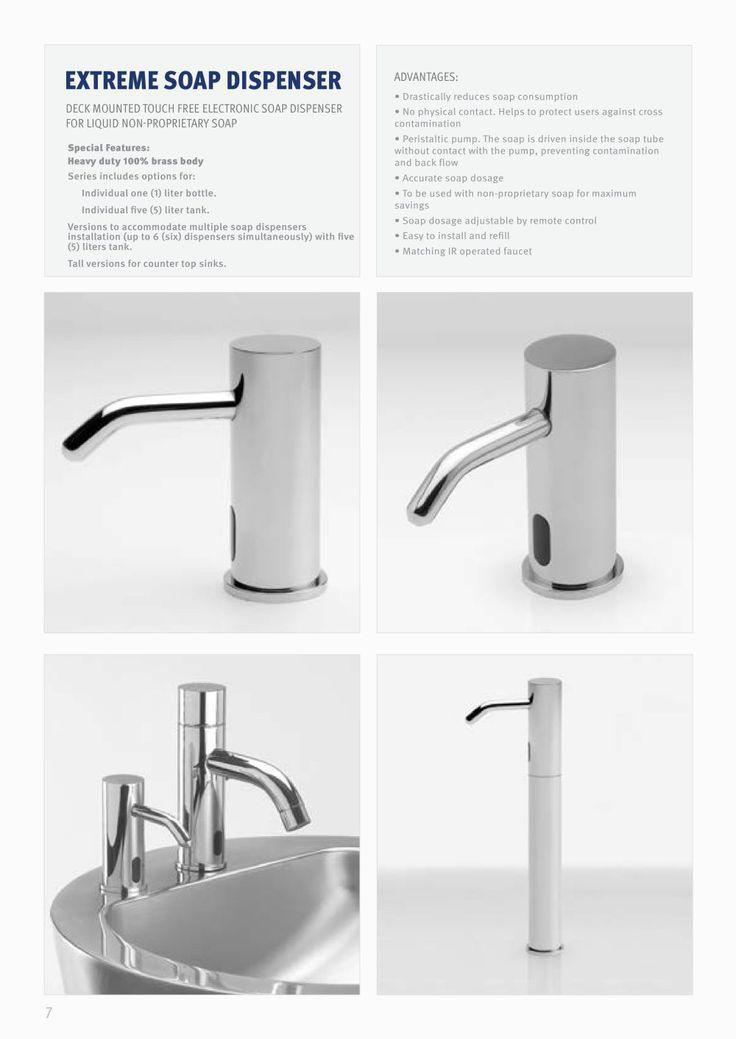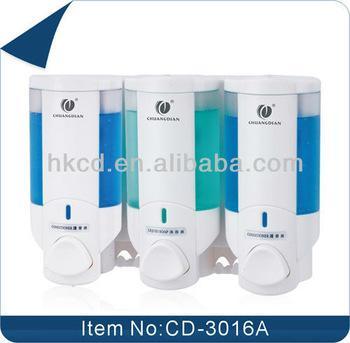The first image is the image on the left, the second image is the image on the right. Examine the images to the left and right. Is the description "1 of the images has 3 dispensers lined up in a row." accurate? Answer yes or no. Yes. The first image is the image on the left, the second image is the image on the right. For the images shown, is this caption "An image shows exactly three side-by-side dispensers." true? Answer yes or no. Yes. 